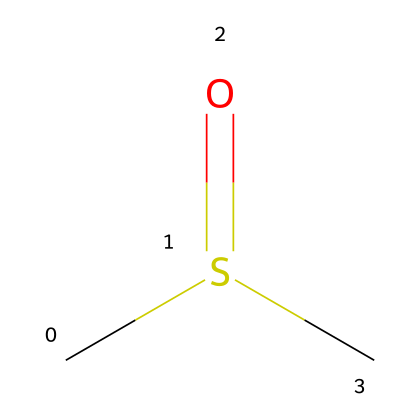What is the molecular formula of the compound represented by this SMILES? The SMILES notation 'CS(=O)C' indicates that the compound comprises one carbon atom (C), one sulfur atom (S), and one oxygen atom (O) along with an additional carbon atom on one side. Thus, the molecular formula is C2H6OS (considering the hydrogens bonded to carbons and the sulfur).
Answer: C2H6OS How many carbon atoms are in this molecule? From the SMILES 'CS(=O)C', we can count the carbon atoms; there are 2 'C' symbols. Thus, there are 2 carbon atoms in total.
Answer: 2 What type of chemical is dimethyl sulfoxide classified as? Dimethyl sulfoxide (DMSO) is classified as an organic solvent based on its molecular structure and properties, as it has a significant polar character which is characteristic of solvents.
Answer: organic solvent What functional group is present in DMSO? The SMILES notation 'CS(=O)C' indicates the presence of a sulfoxide functional group (–S(=O)–), where sulfur is bonded to an oxygen atom with a double bond. This is characteristic of DMSO.
Answer: sulfoxide How many oxygen atoms are in the structure of dimethyl sulfoxide? Analyzing the SMILES 'CS(=O)C', there is one occurrence of the oxygen represented as 'O' and one occurrence in the 'S(=O)', thus there is only one oxygen atom in the compound.
Answer: 1 What is the degree of unsaturation in DMSO? The degree of unsaturation can be estimated by examining the presence of double bonds or rings in the structure. The SMILES 'CS(=O)C' shows a carbon-sulfur double bond, but no rings or further double bonds between carbons; thus it has a degree of unsaturation of 1.
Answer: 1 